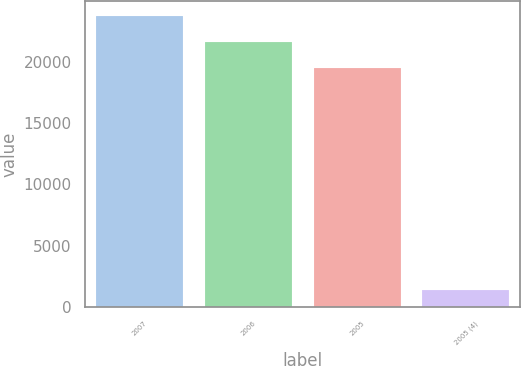<chart> <loc_0><loc_0><loc_500><loc_500><bar_chart><fcel>2007<fcel>2006<fcel>2005<fcel>2005 (4)<nl><fcel>23738.4<fcel>21611.7<fcel>19485<fcel>1414<nl></chart> 